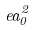Convert formula to latex. <formula><loc_0><loc_0><loc_500><loc_500>e a _ { 0 } ^ { 2 }</formula> 